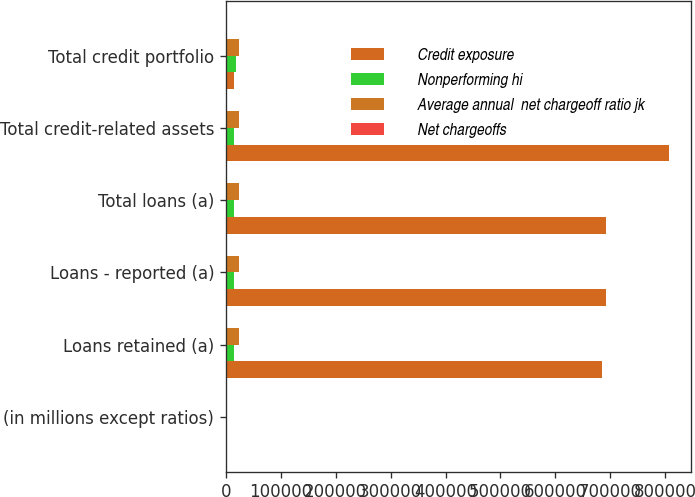Convert chart. <chart><loc_0><loc_0><loc_500><loc_500><stacked_bar_chart><ecel><fcel>(in millions except ratios)<fcel>Loans retained (a)<fcel>Loans - reported (a)<fcel>Total loans (a)<fcel>Total credit-related assets<fcel>Total credit portfolio<nl><fcel>Credit exposure<fcel>2010<fcel>685498<fcel>692927<fcel>692927<fcel>806340<fcel>14841<nl><fcel>Nonperforming hi<fcel>2010<fcel>14345<fcel>14841<fcel>14841<fcel>14875<fcel>17562<nl><fcel>Average annual  net chargeoff ratio jk<fcel>2010<fcel>23673<fcel>23673<fcel>23673<fcel>23673<fcel>23673<nl><fcel>Net chargeoffs<fcel>2010<fcel>3.39<fcel>3.39<fcel>3.39<fcel>3.39<fcel>3.39<nl></chart> 